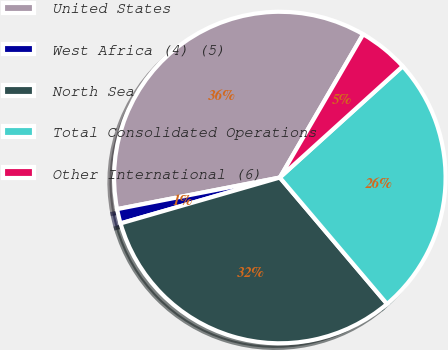Convert chart. <chart><loc_0><loc_0><loc_500><loc_500><pie_chart><fcel>United States<fcel>West Africa (4) (5)<fcel>North Sea<fcel>Total Consolidated Operations<fcel>Other International (6)<nl><fcel>36.44%<fcel>1.41%<fcel>31.73%<fcel>25.52%<fcel>4.9%<nl></chart> 